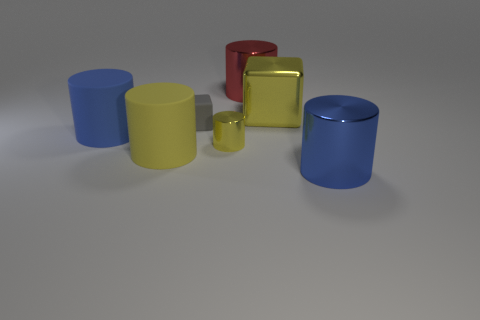What shape is the yellow metallic object that is the same size as the red metallic thing?
Your answer should be compact. Cube. What shape is the yellow thing that is on the right side of the red thing?
Make the answer very short. Cube. Is the number of big yellow metallic blocks that are right of the big blue metallic object less than the number of big objects that are on the left side of the yellow matte cylinder?
Offer a terse response. Yes. Do the blue rubber cylinder and the gray matte block behind the small shiny cylinder have the same size?
Make the answer very short. No. What number of blue rubber cylinders have the same size as the yellow matte object?
Keep it short and to the point. 1. There is another tiny cylinder that is the same material as the red cylinder; what is its color?
Keep it short and to the point. Yellow. Is the number of big rubber cylinders greater than the number of large metal blocks?
Keep it short and to the point. Yes. Does the small gray cube have the same material as the big yellow cylinder?
Offer a very short reply. Yes. There is a yellow thing that is made of the same material as the gray thing; what shape is it?
Give a very brief answer. Cylinder. Is the number of big blue shiny objects less than the number of large matte cylinders?
Provide a short and direct response. Yes. 